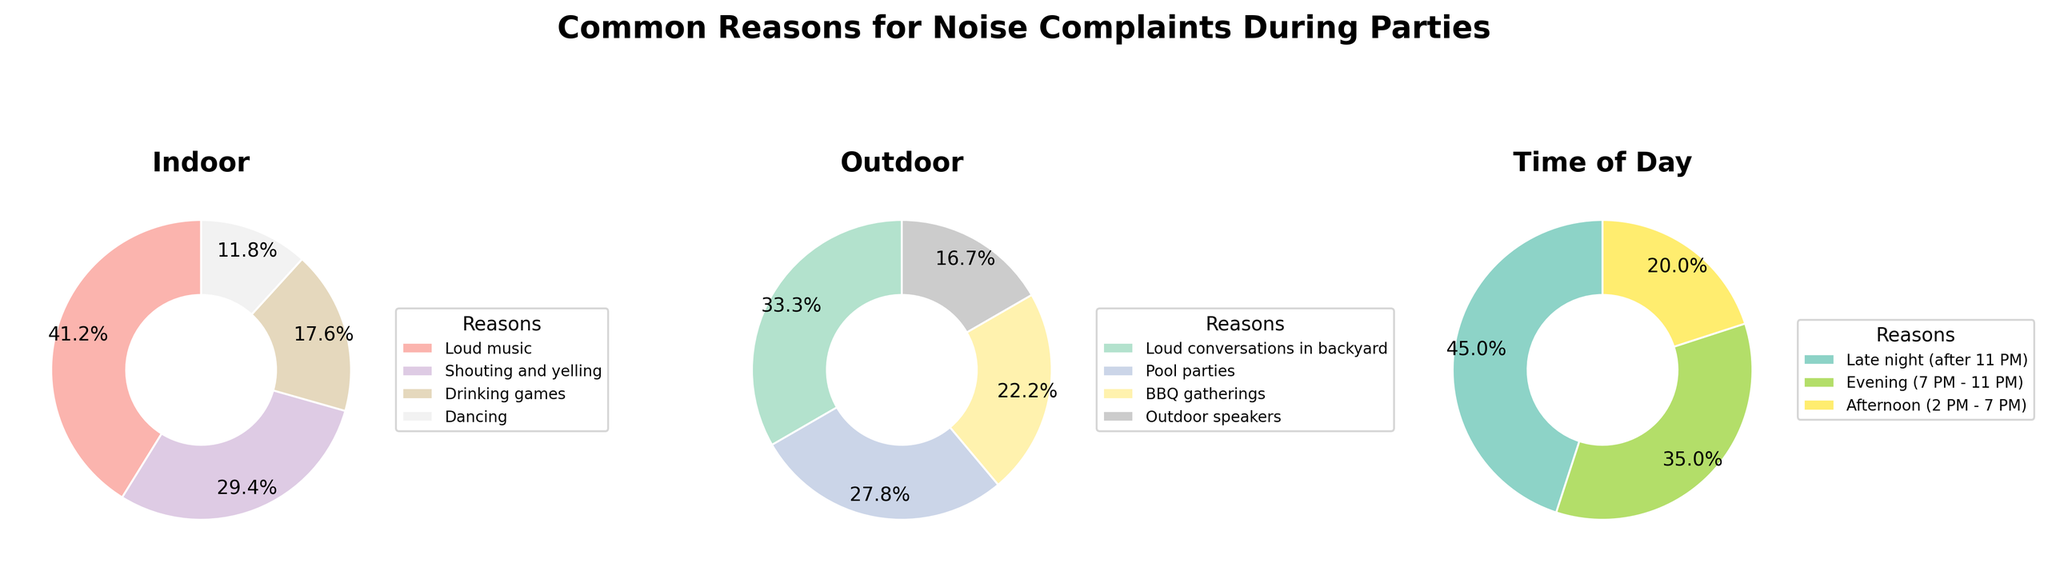What's the title of the figure? The title is displayed at the top of the figure. It reads 'Common Reasons for Noise Complaints During Parties'.
Answer: Common Reasons for Noise Complaints During Parties How much percentage of complaints are due to 'Loud music' indoors? 'Loud music' indoors falls under the 'Indoor' category pie chart. From the chart, it is shown that 'Loud music' accounts for 35%.
Answer: 35% Which outdoor reason has the least percentage of complaints? Look at the 'Outdoor' category pie chart. The lowest percentage is associated with 'Outdoor speakers', which is 15%.
Answer: Outdoor speakers What is the combined percentage of complaints for 'Shouting and yelling' and 'Dancing' indoors? According to the 'Indoor' category pie chart, 'Shouting and yelling' is 25% and 'Dancing' is 10%. Adding them together gives 25% + 10% = 35%.
Answer: 35% During what time of day are the most complaints made? Check the 'Time of Day' category pie chart. The largest slice corresponds to 'Late night (after 11 PM)', which is 45%.
Answer: Late night (after 11 PM) Compare the percentage of complaints due to 'Pool parties' and 'BBQ gatherings'. Which one is higher? In the 'Outdoor' category pie chart, 'Pool parties' account for 25% while 'BBQ gatherings' account for 20%. Hence, 'Pool parties' have a higher percentage.
Answer: Pool parties What's the most common indoor reason and the least common outdoor reason for noise complaints? In the 'Indoor' pie chart, 'Loud music' is the most common reason at 35%. In the 'Outdoor' pie chart, 'Outdoor speakers' is the least common at 15%.
Answer: Loud music (indoor) and Outdoor speakers (outdoor) Which category has the highest overall percentage when considering all reasons? Compare the highest percentages of all three categories. Indoor (Loud music - 35%), Outdoor (Loud conversations in backyard - 30%), Time of Day (Late night - 45%). The highest overall is 'Late night'.
Answer: Late night How do the percentages of 'Loud music' indoors and 'Loud conversations in backyard' outdoors differ? In their respective pie charts, 'Loud music' indoors is 35% and 'Loud conversations in backyard' outdoors is 30%. The difference is 35% - 30% = 5%.
Answer: 5% 